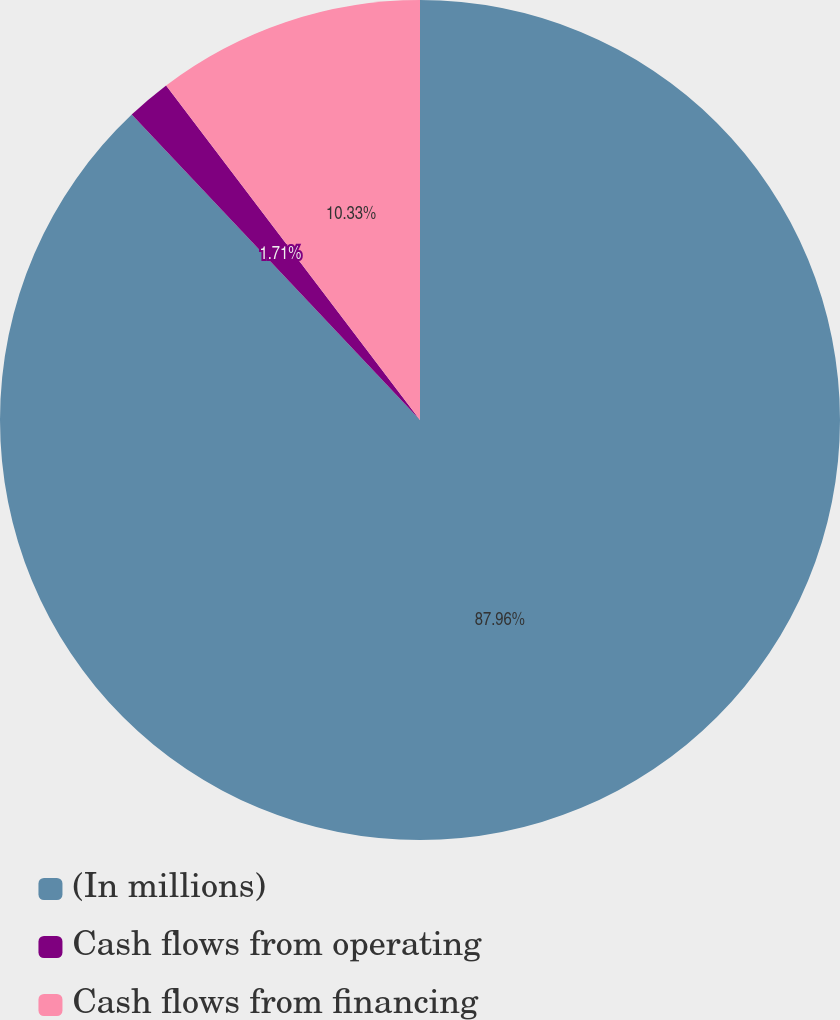Convert chart to OTSL. <chart><loc_0><loc_0><loc_500><loc_500><pie_chart><fcel>(In millions)<fcel>Cash flows from operating<fcel>Cash flows from financing<nl><fcel>87.96%<fcel>1.71%<fcel>10.33%<nl></chart> 